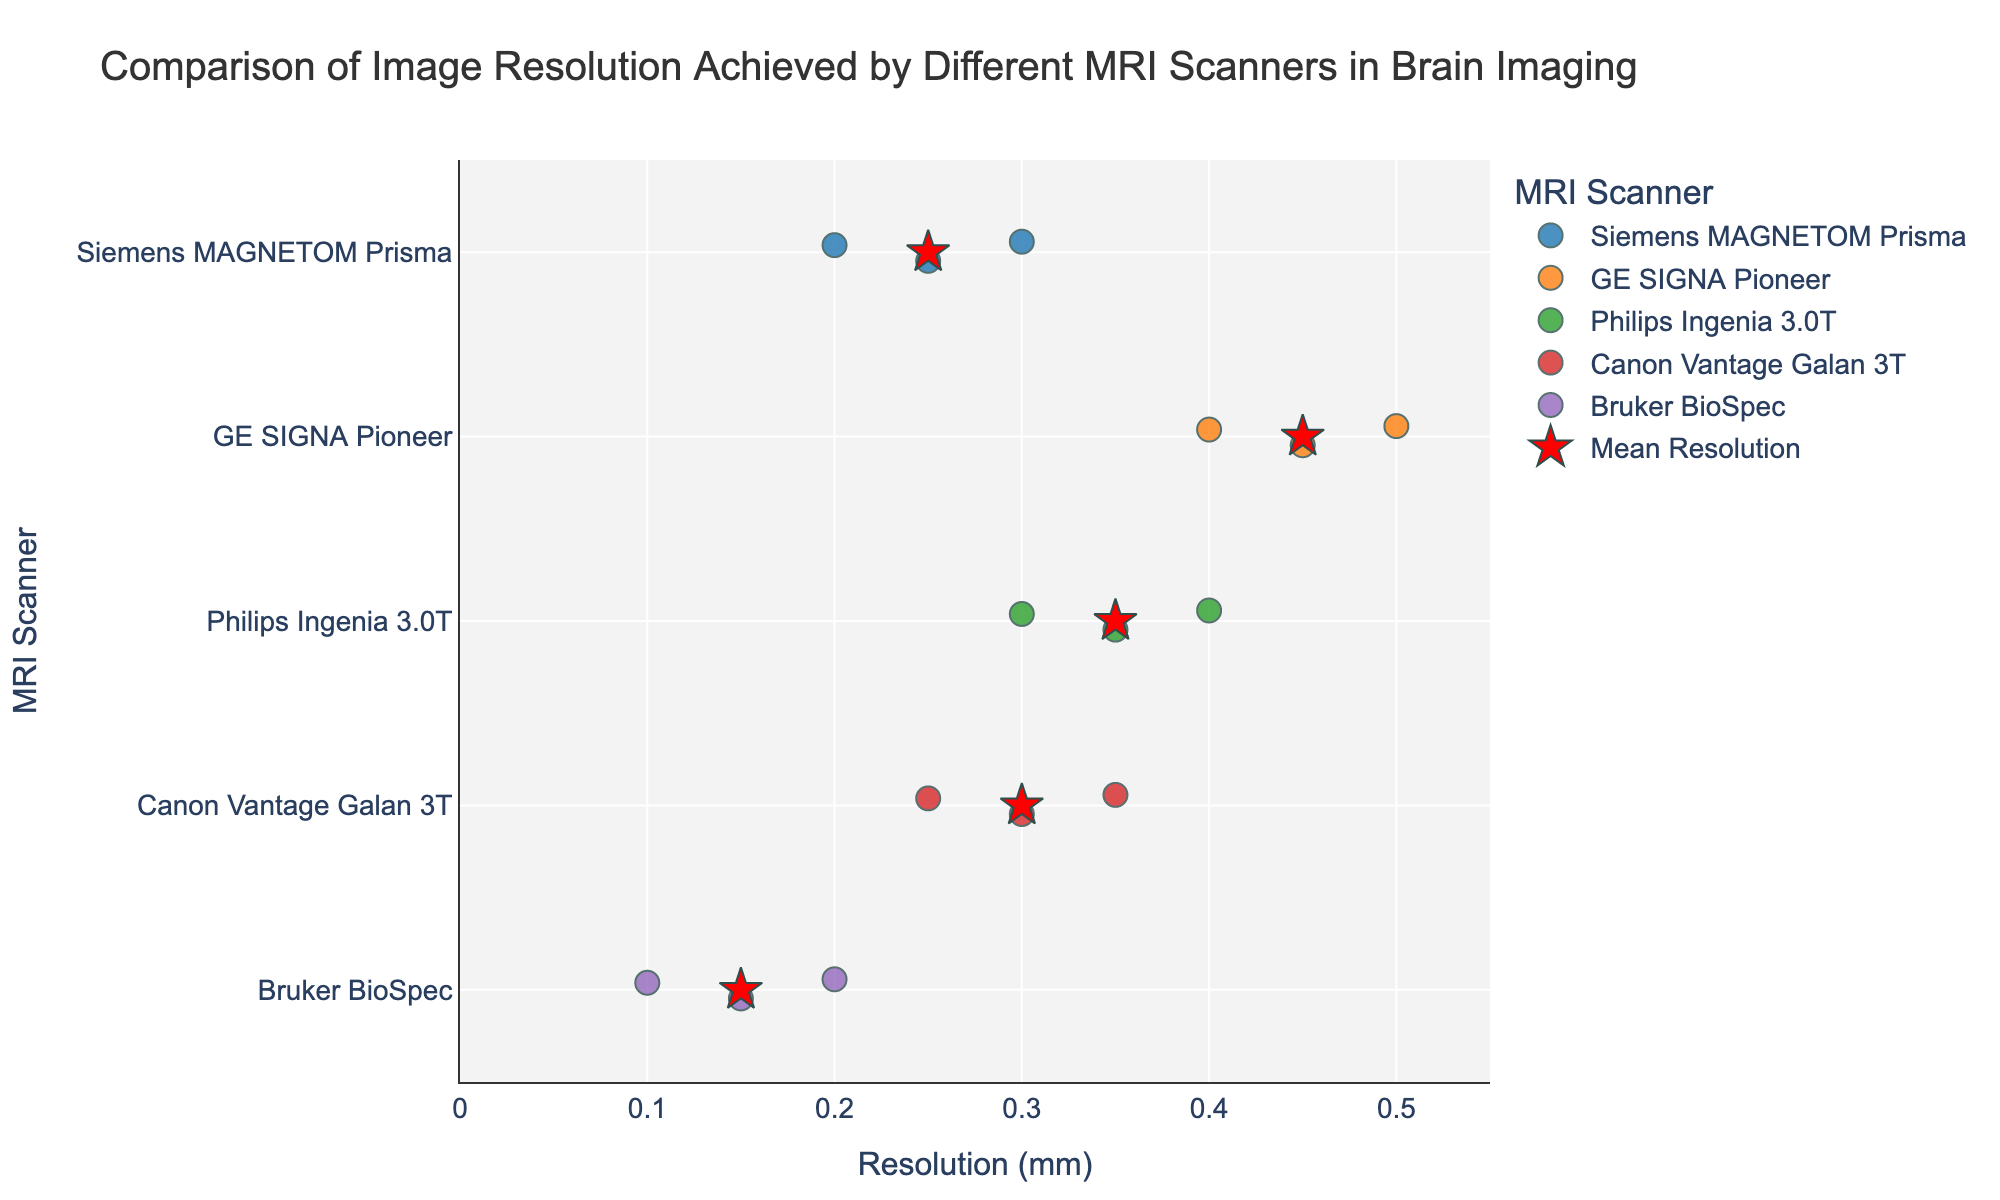What is the title of the figure? The title of the figure is visible at the top and provides information about the figure's content, which is about comparing image resolutions of various MRI scanners.
Answer: Comparison of Image Resolution Achieved by Different MRI Scanners in Brain Imaging What are the labels for the x-axis and y-axis? The labels for the axes are found adjacent to each axis, indicating what each axis represents.
Answer: The x-axis is "Resolution (mm)" and the y-axis is "MRI Scanner" Which scanner has the lowest average resolution? The figure shows mean resolution points marked with red stars. By looking at the positions of these stars, we can identify the lowest one.
Answer: Bruker BioSpec How many data points are there for Philips Ingenia 3.0T? Count the number of individual markers associated with Philips Ingenia 3.0T in the strip plot.
Answer: 3 What is the range of resolutions for the Siemens MAGNETOM Prisma scanner? Identify the minimum and maximum resolution values among the data points for Siemens MAGNETOM Prisma. The range is from the smallest value to the largest value.
Answer: 0.2 to 0.3 mm Which scanner shows the highest individual resolution value? Inspect the x-axis to find the most extreme value and note the scanner it is associated with.
Answer: Bruker BioSpec Compare the average resolutions of GE SIGNA Pioneer and Canon Vantage Galan 3T scanners. Which one is lower? Find the mean resolution points (red stars) for GE SIGNA Pioneer and Canon Vantage Galan 3T, and compare their x-axis positions.
Answer: Canon Vantage Galan 3T How does the resolution variability of GE SIGNA Pioneer compare to Siemens MAGNETOM Prisma? Observe the spread (range) of data points in the strip plots for both scanners. The wider the spread, the higher the variability.
Answer: GE SIGNA Pioneer shows more variability What is the average resolution achieved by the Canon Vantage Galan 3T scanner? Look for the red star marker (mean point) corresponding to the Canon Vantage Galan 3T scanner on the plot.
Answer: 0.3 mm Is there any scanner that has a resolution of exactly 0.3 mm? If so, which ones? Check if any data points align with the resolution of 0.3 mm on the x-axis and note the corresponding scanners.
Answer: Siemens MAGNETOM Prisma, Philips Ingenia 3.0T, Canon Vantage Galan 3T 